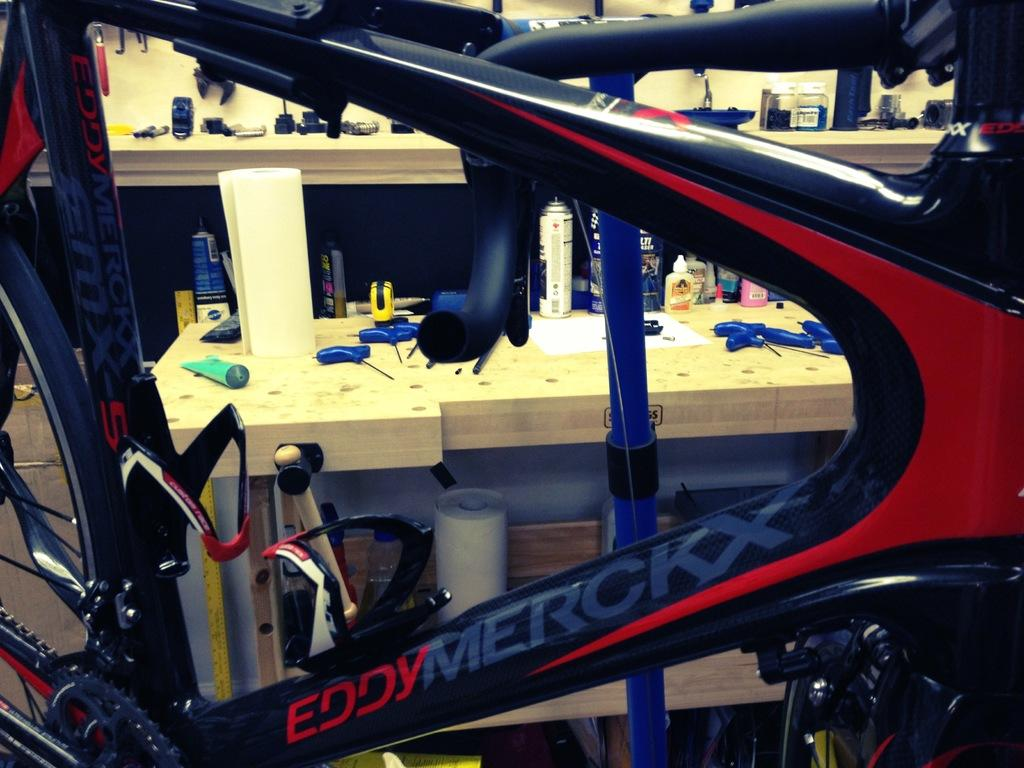What is the main object in the image? There is a bicycle in the image. What else can be seen in the image besides the bicycle? There are objects on tables in the image. What type of tramp is visible in the image? There is no tramp present in the image. What kind of apparatus is being used by the person riding the bicycle in the image? The image does not show a person riding the bicycle, so it is not possible to determine what kind of apparatus they might be using. 